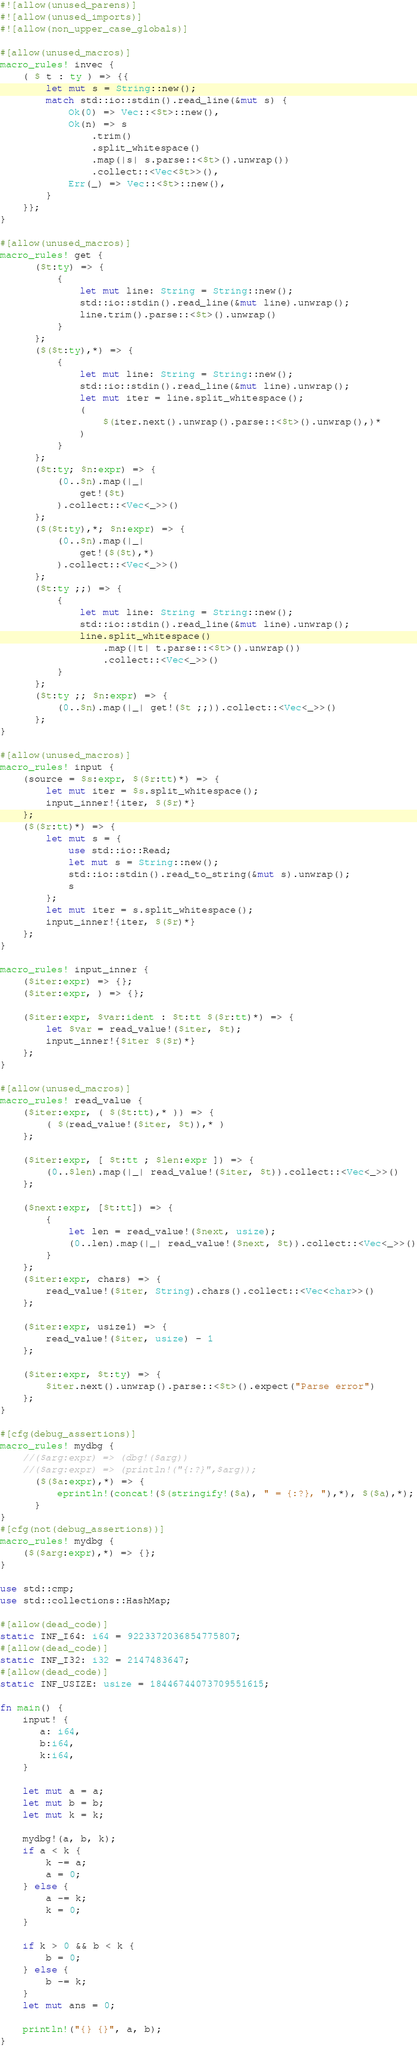<code> <loc_0><loc_0><loc_500><loc_500><_Rust_>#![allow(unused_parens)]
#![allow(unused_imports)]
#![allow(non_upper_case_globals)]

#[allow(unused_macros)]
macro_rules! invec {
    ( $ t : ty ) => {{
        let mut s = String::new();
        match std::io::stdin().read_line(&mut s) {
            Ok(0) => Vec::<$t>::new(),
            Ok(n) => s
                .trim()
                .split_whitespace()
                .map(|s| s.parse::<$t>().unwrap())
                .collect::<Vec<$t>>(),
            Err(_) => Vec::<$t>::new(),
        }
    }};
}

#[allow(unused_macros)]
macro_rules! get {
      ($t:ty) => {
          {
              let mut line: String = String::new();
              std::io::stdin().read_line(&mut line).unwrap();
              line.trim().parse::<$t>().unwrap()
          }
      };
      ($($t:ty),*) => {
          {
              let mut line: String = String::new();
              std::io::stdin().read_line(&mut line).unwrap();
              let mut iter = line.split_whitespace();
              (
                  $(iter.next().unwrap().parse::<$t>().unwrap(),)*
              )
          }
      };
      ($t:ty; $n:expr) => {
          (0..$n).map(|_|
              get!($t)
          ).collect::<Vec<_>>()
      };
      ($($t:ty),*; $n:expr) => {
          (0..$n).map(|_|
              get!($($t),*)
          ).collect::<Vec<_>>()
      };
      ($t:ty ;;) => {
          {
              let mut line: String = String::new();
              std::io::stdin().read_line(&mut line).unwrap();
              line.split_whitespace()
                  .map(|t| t.parse::<$t>().unwrap())
                  .collect::<Vec<_>>()
          }
      };
      ($t:ty ;; $n:expr) => {
          (0..$n).map(|_| get!($t ;;)).collect::<Vec<_>>()
      };
}

#[allow(unused_macros)]
macro_rules! input {
    (source = $s:expr, $($r:tt)*) => {
        let mut iter = $s.split_whitespace();
        input_inner!{iter, $($r)*}
    };
    ($($r:tt)*) => {
        let mut s = {
            use std::io::Read;
            let mut s = String::new();
            std::io::stdin().read_to_string(&mut s).unwrap();
            s
        };
        let mut iter = s.split_whitespace();
        input_inner!{iter, $($r)*}
    };
}

macro_rules! input_inner {
    ($iter:expr) => {};
    ($iter:expr, ) => {};

    ($iter:expr, $var:ident : $t:tt $($r:tt)*) => {
        let $var = read_value!($iter, $t);
        input_inner!{$iter $($r)*}
    };
}

#[allow(unused_macros)]
macro_rules! read_value {
    ($iter:expr, ( $($t:tt),* )) => {
        ( $(read_value!($iter, $t)),* )
    };

    ($iter:expr, [ $t:tt ; $len:expr ]) => {
        (0..$len).map(|_| read_value!($iter, $t)).collect::<Vec<_>>()
    };

    ($next:expr, [$t:tt]) => {
        {
            let len = read_value!($next, usize);
            (0..len).map(|_| read_value!($next, $t)).collect::<Vec<_>>()
        }
    };
    ($iter:expr, chars) => {
        read_value!($iter, String).chars().collect::<Vec<char>>()
    };

    ($iter:expr, usize1) => {
        read_value!($iter, usize) - 1
    };

    ($iter:expr, $t:ty) => {
        $iter.next().unwrap().parse::<$t>().expect("Parse error")
    };
}

#[cfg(debug_assertions)]
macro_rules! mydbg {
    //($arg:expr) => (dbg!($arg))
    //($arg:expr) => (println!("{:?}",$arg));
      ($($a:expr),*) => {
          eprintln!(concat!($(stringify!($a), " = {:?}, "),*), $($a),*);
      }
}
#[cfg(not(debug_assertions))]
macro_rules! mydbg {
    ($($arg:expr),*) => {};
}

use std::cmp;
use std::collections::HashMap;

#[allow(dead_code)]
static INF_I64: i64 = 9223372036854775807;
#[allow(dead_code)]
static INF_I32: i32 = 2147483647;
#[allow(dead_code)]
static INF_USIZE: usize = 18446744073709551615;

fn main() {
    input! {
       a: i64,
       b:i64,
       k:i64,
    }

    let mut a = a;
    let mut b = b;
    let mut k = k;

    mydbg!(a, b, k);
    if a < k {
        k -= a;
        a = 0;
    } else {
        a -= k;
        k = 0;
    }

    if k > 0 && b < k {
        b = 0;
    } else {
        b -= k;
    }
    let mut ans = 0;

    println!("{} {}", a, b);
}
</code> 